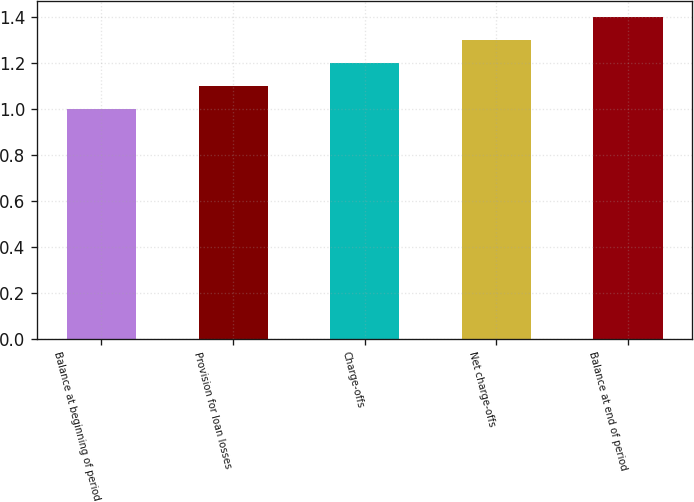Convert chart. <chart><loc_0><loc_0><loc_500><loc_500><bar_chart><fcel>Balance at beginning of period<fcel>Provision for loan losses<fcel>Charge-offs<fcel>Net charge-offs<fcel>Balance at end of period<nl><fcel>1<fcel>1.1<fcel>1.2<fcel>1.3<fcel>1.4<nl></chart> 